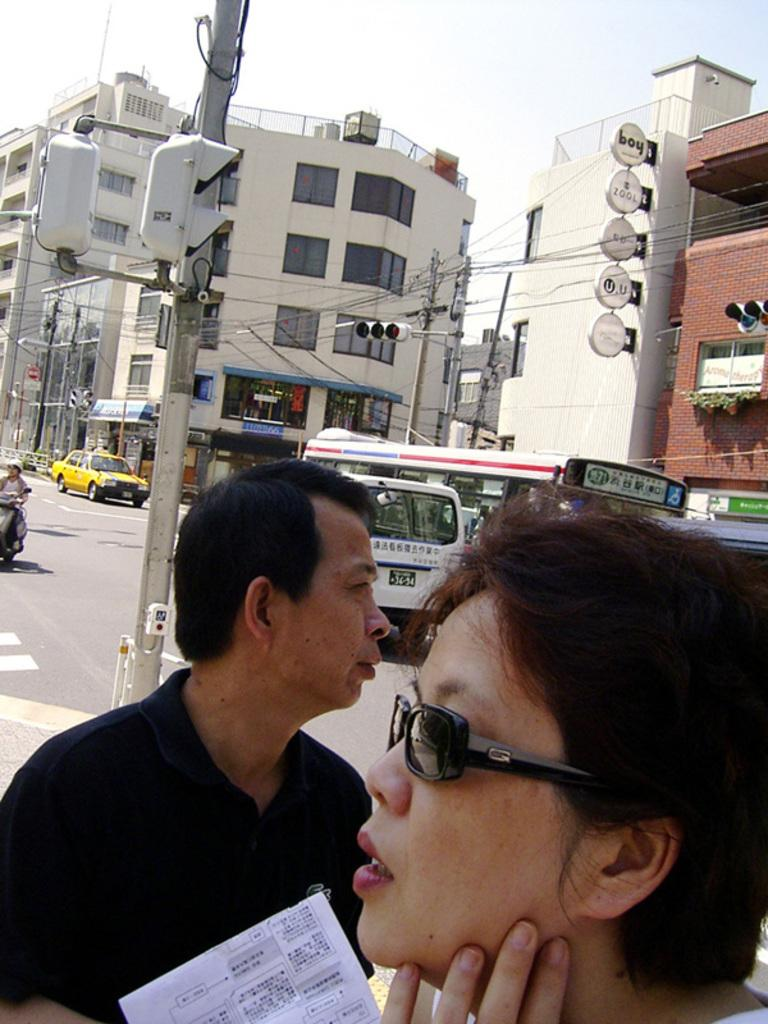How many people are in the image? There are three persons in the image. What else can be seen on the road in the image? There are vehicles on the road in the image. What objects are present in the image that might be used for support or signage? There are poles, lights, and boards in the image. What other infrastructure elements can be seen in the image? There are cables and buildings in the image. What is visible in the background of the image? The sky is visible in the background of the image. What type of bit is being used to paste the distance on the board in the image? There is no bit, paste, or distance present in the image; it only features three persons, vehicles, poles, lights, boards, cables, buildings, and the sky. 